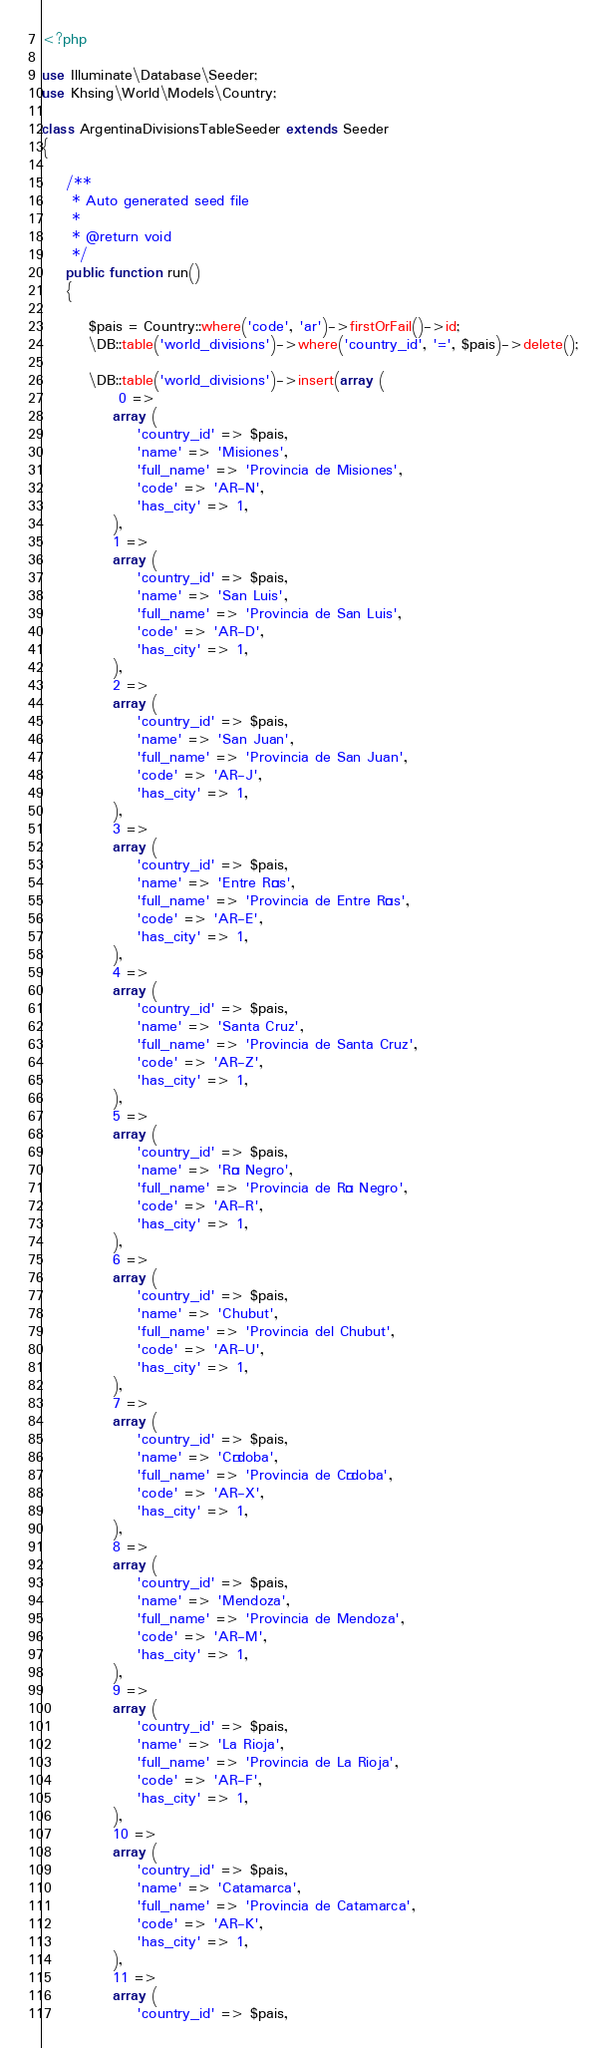Convert code to text. <code><loc_0><loc_0><loc_500><loc_500><_PHP_><?php

use Illuminate\Database\Seeder;
use Khsing\World\Models\Country;

class ArgentinaDivisionsTableSeeder extends Seeder
{

    /**
     * Auto generated seed file
     *
     * @return void
     */
    public function run()
    {
        
        $pais = Country::where('code', 'ar')->firstOrFail()->id;
        \DB::table('world_divisions')->where('country_id', '=', $pais)->delete();
 
        \DB::table('world_divisions')->insert(array (
             0 => 
            array (
                'country_id' => $pais,
                'name' => 'Misiones',
                'full_name' => 'Provincia de Misiones',
                'code' => 'AR-N',
                'has_city' => 1,
            ),
            1 => 
            array (
                'country_id' => $pais,
                'name' => 'San Luis',
                'full_name' => 'Provincia de San Luis',
                'code' => 'AR-D',
                'has_city' => 1,
            ),
            2 => 
            array (
                'country_id' => $pais,
                'name' => 'San Juan',
                'full_name' => 'Provincia de San Juan',
                'code' => 'AR-J',
                'has_city' => 1,
            ),
            3 => 
            array (
                'country_id' => $pais,
                'name' => 'Entre Ríos',
                'full_name' => 'Provincia de Entre Ríos',
                'code' => 'AR-E',
                'has_city' => 1,
            ),
            4 => 
            array (
                'country_id' => $pais,
                'name' => 'Santa Cruz',
                'full_name' => 'Provincia de Santa Cruz',
                'code' => 'AR-Z',
                'has_city' => 1,
            ),
            5 => 
            array (
                'country_id' => $pais,
                'name' => 'Río Negro',
                'full_name' => 'Provincia de Río Negro',
                'code' => 'AR-R',
                'has_city' => 1,
            ),
            6 => 
            array (
                'country_id' => $pais,
                'name' => 'Chubut',
                'full_name' => 'Provincia del Chubut',
                'code' => 'AR-U',
                'has_city' => 1,
            ),
            7 => 
            array (
                'country_id' => $pais,
                'name' => 'Córdoba',
                'full_name' => 'Provincia de Córdoba',
                'code' => 'AR-X',
                'has_city' => 1,
            ),
            8 => 
            array (
                'country_id' => $pais,
                'name' => 'Mendoza',
                'full_name' => 'Provincia de Mendoza',
                'code' => 'AR-M',
                'has_city' => 1,
            ),
            9 => 
            array (
                'country_id' => $pais,
                'name' => 'La Rioja',
                'full_name' => 'Provincia de La Rioja',
                'code' => 'AR-F',
                'has_city' => 1,
            ),
            10 => 
            array (
                'country_id' => $pais,
                'name' => 'Catamarca',
                'full_name' => 'Provincia de Catamarca',
                'code' => 'AR-K',
                'has_city' => 1,
            ),
            11 => 
            array (
                'country_id' => $pais,</code> 